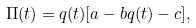Convert formula to latex. <formula><loc_0><loc_0><loc_500><loc_500>\Pi ( t ) = q ( t ) [ a - b q ( t ) - c ] ,</formula> 